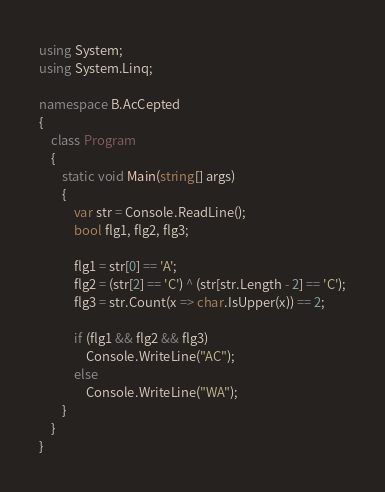<code> <loc_0><loc_0><loc_500><loc_500><_C#_>using System;
using System.Linq;

namespace B.AcCepted
{
    class Program
    {
        static void Main(string[] args)
        {
            var str = Console.ReadLine();
            bool flg1, flg2, flg3;

            flg1 = str[0] == 'A';
            flg2 = (str[2] == 'C') ^ (str[str.Length - 2] == 'C');
            flg3 = str.Count(x => char.IsUpper(x)) == 2;

            if (flg1 && flg2 && flg3)
                Console.WriteLine("AC");
            else
                Console.WriteLine("WA");
        }
    }
}
</code> 